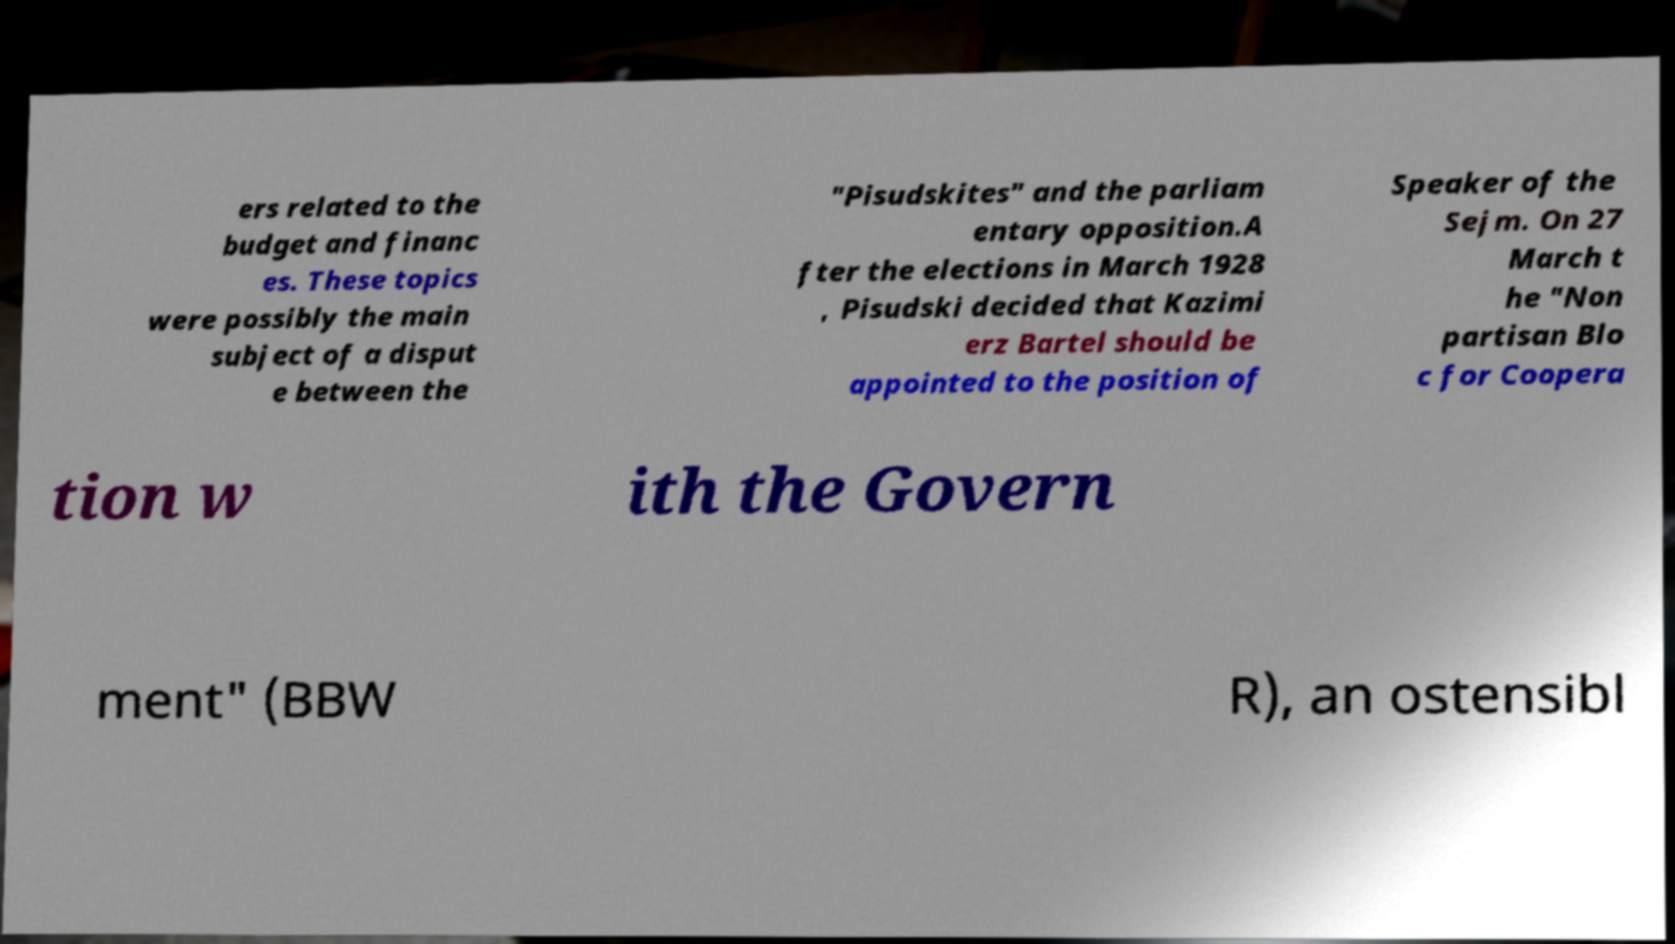Please read and relay the text visible in this image. What does it say? ers related to the budget and financ es. These topics were possibly the main subject of a disput e between the "Pisudskites" and the parliam entary opposition.A fter the elections in March 1928 , Pisudski decided that Kazimi erz Bartel should be appointed to the position of Speaker of the Sejm. On 27 March t he "Non partisan Blo c for Coopera tion w ith the Govern ment" (BBW R), an ostensibl 